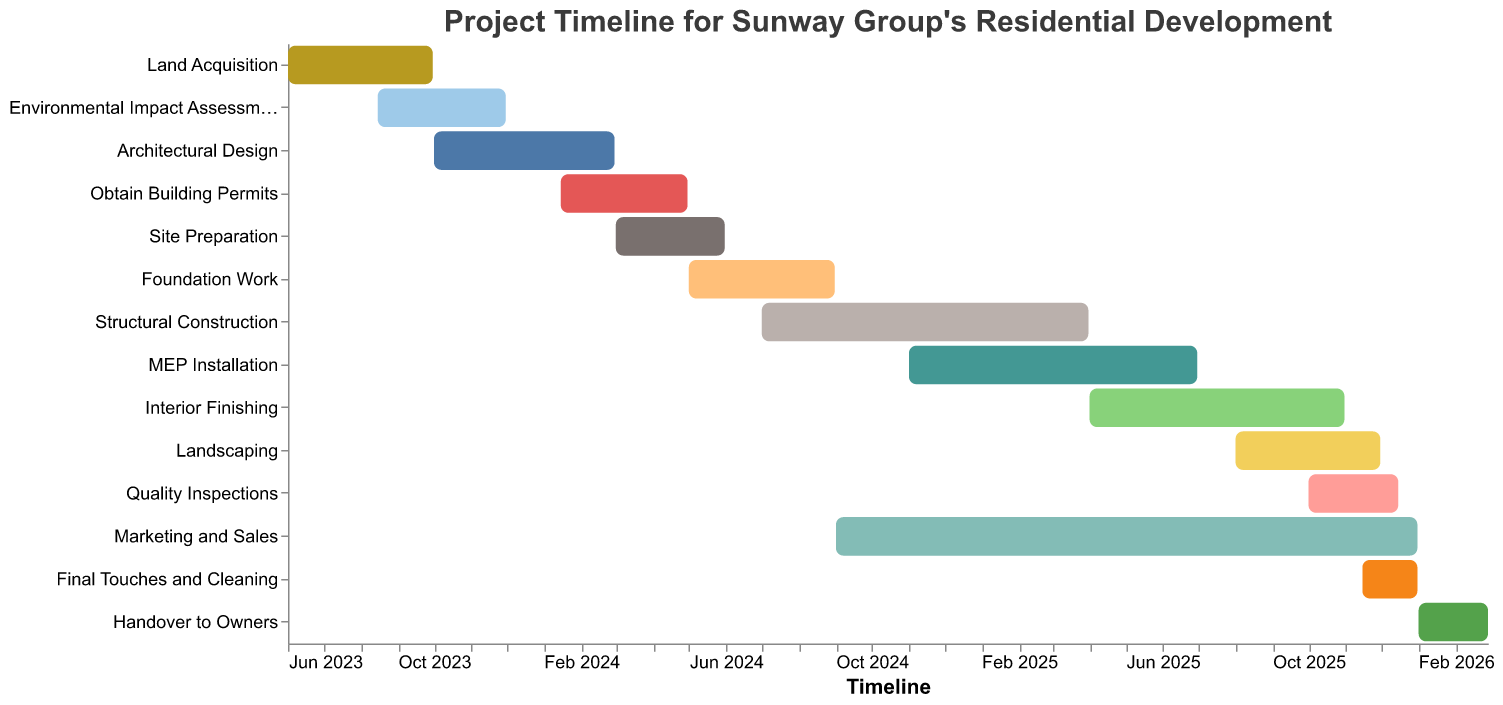What is the duration of the Land Acquisition phase? Identify the start and end dates for the task "Land Acquisition" (June 1, 2023, to September 30, 2023). Calculate the difference between the two dates.
Answer: Approximately 4 months What phases overlap with the Environmental Impact Assessment? Identify the other tasks and their timelines that have any timeframe in common with the Environmental Impact Assessment, which is from August 15, 2023, to November 30, 2023. The overlapping phases are Land Acquisition and Architectural Design.
Answer: Land Acquisition, Architectural Design Which phase lasts the longest and how long is it? Compare the duration of each phase by calculating the difference between their start and end dates. The Marketing and Sales phase from September 1, 2024, to December 31, 2025, is the longest.
Answer: Marketing and Sales, about 16 months How much time elapses from the start of Site Preparation to the end of MEP Installation? Identify the start date of Site Preparation (March 1, 2024) and the end date of MEP Installation (June 30, 2025). Calculate the total duration between these dates.
Answer: Approximately 16 months Which tasks are scheduled to start in the year 2025? Look for the tasks whose start dates fall within the year 2025. The tasks that start in 2025 are Landscaping, Quality Inspections, Interior Finishing, Final Touches and Cleaning.
Answer: Landscaping, Quality Inspections, Interior Finishing, Final Touches and Cleaning When does Structural Construction begin and end? Identify the start and end dates for the task "Structural Construction" from the chart. Structural Construction starts on July 1, 2024, and ends on March 31, 2025.
Answer: July 1, 2024, to March 31, 2025 Which phases are completed by the end of 2024? Identify the tasks which have end dates before or on December 31, 2024. These tasks are Land Acquisition, Environmental Impact Assessment, Architectural Design, Obtain Building Permits, Site Preparation, Foundation Work, and Structural Construction.
Answer: Land Acquisition, Environmental Impact Assessment, Architectural Design, Obtain Building Permits, Site Preparation, Foundation Work How does the duration of the Handover to Owners compare to the Final Touches and Cleaning? Calculate the duration for "Handover to Owners" (January 1, 2026, to February 28, 2026) and "Final Touches and Cleaning" (November 15, 2025, to December 31, 2025). Compare the durations.
Answer: Handover to Owners: ~2 months, Final Touches and Cleaning: ~1.5 months 